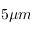<formula> <loc_0><loc_0><loc_500><loc_500>5 \mu m</formula> 